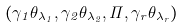<formula> <loc_0><loc_0><loc_500><loc_500>( \gamma _ { 1 } \theta _ { \lambda _ { 1 } } , \gamma _ { 2 } \theta _ { \lambda _ { 2 } } , \cdots , \gamma _ { r } \theta _ { \lambda _ { r } } )</formula> 